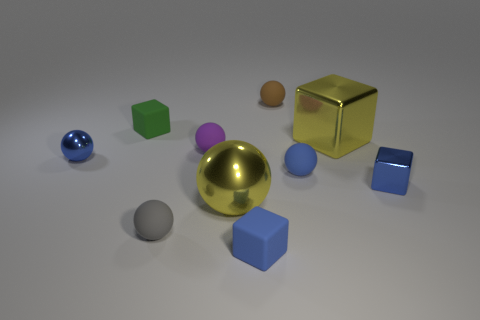Subtract all blue spheres. How many spheres are left? 4 Subtract all purple spheres. How many spheres are left? 5 Subtract all cyan spheres. Subtract all cyan cylinders. How many spheres are left? 6 Subtract all cubes. How many objects are left? 6 Subtract all large purple blocks. Subtract all small gray rubber objects. How many objects are left? 9 Add 4 green blocks. How many green blocks are left? 5 Add 1 tiny purple rubber objects. How many tiny purple rubber objects exist? 2 Subtract 0 cyan spheres. How many objects are left? 10 